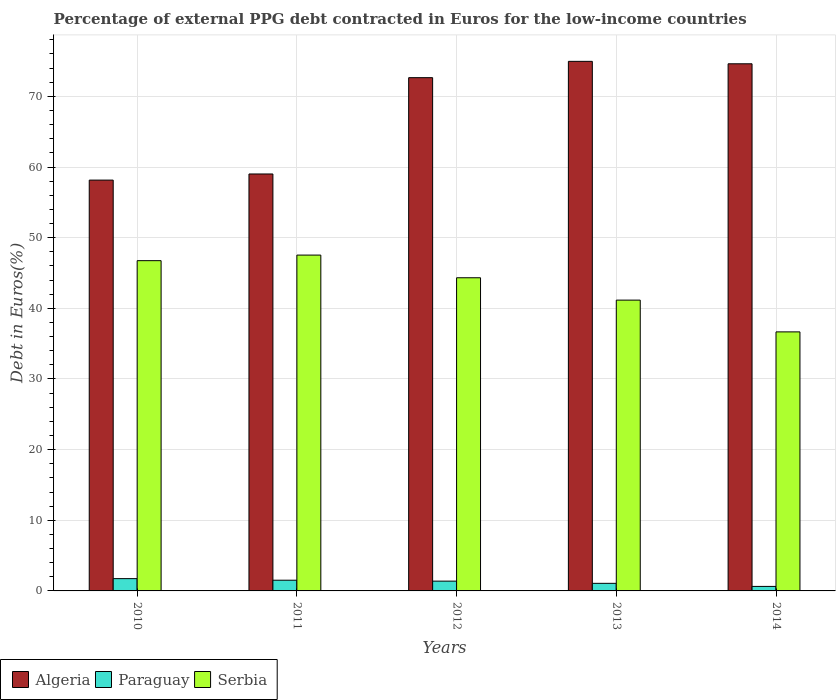Are the number of bars per tick equal to the number of legend labels?
Your response must be concise. Yes. Are the number of bars on each tick of the X-axis equal?
Offer a very short reply. Yes. How many bars are there on the 3rd tick from the left?
Offer a terse response. 3. What is the label of the 1st group of bars from the left?
Ensure brevity in your answer.  2010. What is the percentage of external PPG debt contracted in Euros in Serbia in 2013?
Keep it short and to the point. 41.16. Across all years, what is the maximum percentage of external PPG debt contracted in Euros in Paraguay?
Your answer should be compact. 1.74. Across all years, what is the minimum percentage of external PPG debt contracted in Euros in Algeria?
Keep it short and to the point. 58.15. In which year was the percentage of external PPG debt contracted in Euros in Serbia maximum?
Ensure brevity in your answer.  2011. What is the total percentage of external PPG debt contracted in Euros in Paraguay in the graph?
Your answer should be very brief. 6.35. What is the difference between the percentage of external PPG debt contracted in Euros in Algeria in 2010 and that in 2011?
Your response must be concise. -0.87. What is the difference between the percentage of external PPG debt contracted in Euros in Paraguay in 2010 and the percentage of external PPG debt contracted in Euros in Algeria in 2012?
Make the answer very short. -70.91. What is the average percentage of external PPG debt contracted in Euros in Algeria per year?
Your response must be concise. 67.87. In the year 2013, what is the difference between the percentage of external PPG debt contracted in Euros in Paraguay and percentage of external PPG debt contracted in Euros in Serbia?
Keep it short and to the point. -40.09. What is the ratio of the percentage of external PPG debt contracted in Euros in Algeria in 2012 to that in 2013?
Offer a terse response. 0.97. What is the difference between the highest and the second highest percentage of external PPG debt contracted in Euros in Paraguay?
Offer a terse response. 0.22. What is the difference between the highest and the lowest percentage of external PPG debt contracted in Euros in Paraguay?
Give a very brief answer. 1.1. What does the 2nd bar from the left in 2012 represents?
Offer a very short reply. Paraguay. What does the 3rd bar from the right in 2012 represents?
Ensure brevity in your answer.  Algeria. How many bars are there?
Provide a succinct answer. 15. Are all the bars in the graph horizontal?
Give a very brief answer. No. How many years are there in the graph?
Keep it short and to the point. 5. What is the difference between two consecutive major ticks on the Y-axis?
Make the answer very short. 10. How many legend labels are there?
Your response must be concise. 3. How are the legend labels stacked?
Provide a succinct answer. Horizontal. What is the title of the graph?
Provide a short and direct response. Percentage of external PPG debt contracted in Euros for the low-income countries. Does "Spain" appear as one of the legend labels in the graph?
Make the answer very short. No. What is the label or title of the X-axis?
Your response must be concise. Years. What is the label or title of the Y-axis?
Offer a very short reply. Debt in Euros(%). What is the Debt in Euros(%) in Algeria in 2010?
Your response must be concise. 58.15. What is the Debt in Euros(%) of Paraguay in 2010?
Provide a succinct answer. 1.74. What is the Debt in Euros(%) in Serbia in 2010?
Offer a terse response. 46.74. What is the Debt in Euros(%) in Algeria in 2011?
Make the answer very short. 59.01. What is the Debt in Euros(%) of Paraguay in 2011?
Your response must be concise. 1.52. What is the Debt in Euros(%) in Serbia in 2011?
Your response must be concise. 47.53. What is the Debt in Euros(%) in Algeria in 2012?
Make the answer very short. 72.64. What is the Debt in Euros(%) of Paraguay in 2012?
Your response must be concise. 1.39. What is the Debt in Euros(%) in Serbia in 2012?
Provide a short and direct response. 44.32. What is the Debt in Euros(%) in Algeria in 2013?
Provide a short and direct response. 74.95. What is the Debt in Euros(%) in Paraguay in 2013?
Offer a very short reply. 1.07. What is the Debt in Euros(%) of Serbia in 2013?
Provide a short and direct response. 41.16. What is the Debt in Euros(%) in Algeria in 2014?
Offer a terse response. 74.61. What is the Debt in Euros(%) in Paraguay in 2014?
Offer a terse response. 0.64. What is the Debt in Euros(%) of Serbia in 2014?
Offer a terse response. 36.66. Across all years, what is the maximum Debt in Euros(%) in Algeria?
Your answer should be compact. 74.95. Across all years, what is the maximum Debt in Euros(%) in Paraguay?
Provide a succinct answer. 1.74. Across all years, what is the maximum Debt in Euros(%) of Serbia?
Your response must be concise. 47.53. Across all years, what is the minimum Debt in Euros(%) of Algeria?
Offer a terse response. 58.15. Across all years, what is the minimum Debt in Euros(%) of Paraguay?
Your answer should be very brief. 0.64. Across all years, what is the minimum Debt in Euros(%) of Serbia?
Offer a terse response. 36.66. What is the total Debt in Euros(%) in Algeria in the graph?
Your answer should be compact. 339.37. What is the total Debt in Euros(%) of Paraguay in the graph?
Ensure brevity in your answer.  6.35. What is the total Debt in Euros(%) in Serbia in the graph?
Provide a short and direct response. 216.42. What is the difference between the Debt in Euros(%) in Algeria in 2010 and that in 2011?
Your answer should be compact. -0.87. What is the difference between the Debt in Euros(%) in Paraguay in 2010 and that in 2011?
Keep it short and to the point. 0.22. What is the difference between the Debt in Euros(%) in Serbia in 2010 and that in 2011?
Make the answer very short. -0.79. What is the difference between the Debt in Euros(%) in Algeria in 2010 and that in 2012?
Provide a short and direct response. -14.5. What is the difference between the Debt in Euros(%) of Paraguay in 2010 and that in 2012?
Offer a very short reply. 0.35. What is the difference between the Debt in Euros(%) in Serbia in 2010 and that in 2012?
Ensure brevity in your answer.  2.42. What is the difference between the Debt in Euros(%) in Algeria in 2010 and that in 2013?
Your response must be concise. -16.81. What is the difference between the Debt in Euros(%) in Paraguay in 2010 and that in 2013?
Give a very brief answer. 0.66. What is the difference between the Debt in Euros(%) of Serbia in 2010 and that in 2013?
Provide a succinct answer. 5.58. What is the difference between the Debt in Euros(%) in Algeria in 2010 and that in 2014?
Provide a short and direct response. -16.46. What is the difference between the Debt in Euros(%) in Paraguay in 2010 and that in 2014?
Your answer should be compact. 1.1. What is the difference between the Debt in Euros(%) of Serbia in 2010 and that in 2014?
Keep it short and to the point. 10.08. What is the difference between the Debt in Euros(%) in Algeria in 2011 and that in 2012?
Your answer should be compact. -13.63. What is the difference between the Debt in Euros(%) of Paraguay in 2011 and that in 2012?
Make the answer very short. 0.13. What is the difference between the Debt in Euros(%) of Serbia in 2011 and that in 2012?
Ensure brevity in your answer.  3.21. What is the difference between the Debt in Euros(%) in Algeria in 2011 and that in 2013?
Your response must be concise. -15.94. What is the difference between the Debt in Euros(%) of Paraguay in 2011 and that in 2013?
Offer a very short reply. 0.44. What is the difference between the Debt in Euros(%) of Serbia in 2011 and that in 2013?
Your response must be concise. 6.37. What is the difference between the Debt in Euros(%) in Algeria in 2011 and that in 2014?
Your response must be concise. -15.6. What is the difference between the Debt in Euros(%) of Paraguay in 2011 and that in 2014?
Your answer should be compact. 0.88. What is the difference between the Debt in Euros(%) in Serbia in 2011 and that in 2014?
Ensure brevity in your answer.  10.87. What is the difference between the Debt in Euros(%) of Algeria in 2012 and that in 2013?
Keep it short and to the point. -2.31. What is the difference between the Debt in Euros(%) of Paraguay in 2012 and that in 2013?
Your answer should be compact. 0.31. What is the difference between the Debt in Euros(%) in Serbia in 2012 and that in 2013?
Provide a succinct answer. 3.16. What is the difference between the Debt in Euros(%) in Algeria in 2012 and that in 2014?
Give a very brief answer. -1.96. What is the difference between the Debt in Euros(%) of Paraguay in 2012 and that in 2014?
Your answer should be very brief. 0.75. What is the difference between the Debt in Euros(%) in Serbia in 2012 and that in 2014?
Provide a short and direct response. 7.66. What is the difference between the Debt in Euros(%) in Algeria in 2013 and that in 2014?
Offer a terse response. 0.34. What is the difference between the Debt in Euros(%) in Paraguay in 2013 and that in 2014?
Offer a terse response. 0.44. What is the difference between the Debt in Euros(%) of Serbia in 2013 and that in 2014?
Give a very brief answer. 4.5. What is the difference between the Debt in Euros(%) in Algeria in 2010 and the Debt in Euros(%) in Paraguay in 2011?
Your answer should be very brief. 56.63. What is the difference between the Debt in Euros(%) in Algeria in 2010 and the Debt in Euros(%) in Serbia in 2011?
Keep it short and to the point. 10.61. What is the difference between the Debt in Euros(%) in Paraguay in 2010 and the Debt in Euros(%) in Serbia in 2011?
Provide a succinct answer. -45.79. What is the difference between the Debt in Euros(%) of Algeria in 2010 and the Debt in Euros(%) of Paraguay in 2012?
Ensure brevity in your answer.  56.76. What is the difference between the Debt in Euros(%) of Algeria in 2010 and the Debt in Euros(%) of Serbia in 2012?
Provide a short and direct response. 13.82. What is the difference between the Debt in Euros(%) in Paraguay in 2010 and the Debt in Euros(%) in Serbia in 2012?
Offer a terse response. -42.58. What is the difference between the Debt in Euros(%) in Algeria in 2010 and the Debt in Euros(%) in Paraguay in 2013?
Offer a terse response. 57.07. What is the difference between the Debt in Euros(%) in Algeria in 2010 and the Debt in Euros(%) in Serbia in 2013?
Provide a short and direct response. 16.99. What is the difference between the Debt in Euros(%) in Paraguay in 2010 and the Debt in Euros(%) in Serbia in 2013?
Make the answer very short. -39.42. What is the difference between the Debt in Euros(%) in Algeria in 2010 and the Debt in Euros(%) in Paraguay in 2014?
Your response must be concise. 57.51. What is the difference between the Debt in Euros(%) of Algeria in 2010 and the Debt in Euros(%) of Serbia in 2014?
Keep it short and to the point. 21.48. What is the difference between the Debt in Euros(%) of Paraguay in 2010 and the Debt in Euros(%) of Serbia in 2014?
Ensure brevity in your answer.  -34.92. What is the difference between the Debt in Euros(%) in Algeria in 2011 and the Debt in Euros(%) in Paraguay in 2012?
Offer a very short reply. 57.63. What is the difference between the Debt in Euros(%) in Algeria in 2011 and the Debt in Euros(%) in Serbia in 2012?
Your answer should be very brief. 14.69. What is the difference between the Debt in Euros(%) of Paraguay in 2011 and the Debt in Euros(%) of Serbia in 2012?
Make the answer very short. -42.81. What is the difference between the Debt in Euros(%) of Algeria in 2011 and the Debt in Euros(%) of Paraguay in 2013?
Ensure brevity in your answer.  57.94. What is the difference between the Debt in Euros(%) in Algeria in 2011 and the Debt in Euros(%) in Serbia in 2013?
Make the answer very short. 17.85. What is the difference between the Debt in Euros(%) in Paraguay in 2011 and the Debt in Euros(%) in Serbia in 2013?
Your answer should be compact. -39.64. What is the difference between the Debt in Euros(%) of Algeria in 2011 and the Debt in Euros(%) of Paraguay in 2014?
Give a very brief answer. 58.38. What is the difference between the Debt in Euros(%) of Algeria in 2011 and the Debt in Euros(%) of Serbia in 2014?
Ensure brevity in your answer.  22.35. What is the difference between the Debt in Euros(%) of Paraguay in 2011 and the Debt in Euros(%) of Serbia in 2014?
Provide a succinct answer. -35.15. What is the difference between the Debt in Euros(%) of Algeria in 2012 and the Debt in Euros(%) of Paraguay in 2013?
Give a very brief answer. 71.57. What is the difference between the Debt in Euros(%) of Algeria in 2012 and the Debt in Euros(%) of Serbia in 2013?
Give a very brief answer. 31.49. What is the difference between the Debt in Euros(%) of Paraguay in 2012 and the Debt in Euros(%) of Serbia in 2013?
Offer a very short reply. -39.77. What is the difference between the Debt in Euros(%) in Algeria in 2012 and the Debt in Euros(%) in Paraguay in 2014?
Offer a very short reply. 72.01. What is the difference between the Debt in Euros(%) in Algeria in 2012 and the Debt in Euros(%) in Serbia in 2014?
Offer a terse response. 35.98. What is the difference between the Debt in Euros(%) of Paraguay in 2012 and the Debt in Euros(%) of Serbia in 2014?
Your answer should be compact. -35.28. What is the difference between the Debt in Euros(%) in Algeria in 2013 and the Debt in Euros(%) in Paraguay in 2014?
Give a very brief answer. 74.32. What is the difference between the Debt in Euros(%) of Algeria in 2013 and the Debt in Euros(%) of Serbia in 2014?
Your answer should be very brief. 38.29. What is the difference between the Debt in Euros(%) in Paraguay in 2013 and the Debt in Euros(%) in Serbia in 2014?
Provide a short and direct response. -35.59. What is the average Debt in Euros(%) of Algeria per year?
Your answer should be very brief. 67.87. What is the average Debt in Euros(%) in Paraguay per year?
Your response must be concise. 1.27. What is the average Debt in Euros(%) in Serbia per year?
Offer a very short reply. 43.28. In the year 2010, what is the difference between the Debt in Euros(%) of Algeria and Debt in Euros(%) of Paraguay?
Give a very brief answer. 56.41. In the year 2010, what is the difference between the Debt in Euros(%) in Algeria and Debt in Euros(%) in Serbia?
Provide a succinct answer. 11.4. In the year 2010, what is the difference between the Debt in Euros(%) of Paraguay and Debt in Euros(%) of Serbia?
Your response must be concise. -45. In the year 2011, what is the difference between the Debt in Euros(%) in Algeria and Debt in Euros(%) in Paraguay?
Provide a short and direct response. 57.5. In the year 2011, what is the difference between the Debt in Euros(%) in Algeria and Debt in Euros(%) in Serbia?
Offer a terse response. 11.48. In the year 2011, what is the difference between the Debt in Euros(%) in Paraguay and Debt in Euros(%) in Serbia?
Make the answer very short. -46.02. In the year 2012, what is the difference between the Debt in Euros(%) in Algeria and Debt in Euros(%) in Paraguay?
Your response must be concise. 71.26. In the year 2012, what is the difference between the Debt in Euros(%) of Algeria and Debt in Euros(%) of Serbia?
Keep it short and to the point. 28.32. In the year 2012, what is the difference between the Debt in Euros(%) in Paraguay and Debt in Euros(%) in Serbia?
Your answer should be compact. -42.94. In the year 2013, what is the difference between the Debt in Euros(%) of Algeria and Debt in Euros(%) of Paraguay?
Provide a short and direct response. 73.88. In the year 2013, what is the difference between the Debt in Euros(%) of Algeria and Debt in Euros(%) of Serbia?
Offer a very short reply. 33.79. In the year 2013, what is the difference between the Debt in Euros(%) of Paraguay and Debt in Euros(%) of Serbia?
Provide a succinct answer. -40.09. In the year 2014, what is the difference between the Debt in Euros(%) in Algeria and Debt in Euros(%) in Paraguay?
Give a very brief answer. 73.97. In the year 2014, what is the difference between the Debt in Euros(%) in Algeria and Debt in Euros(%) in Serbia?
Make the answer very short. 37.95. In the year 2014, what is the difference between the Debt in Euros(%) in Paraguay and Debt in Euros(%) in Serbia?
Make the answer very short. -36.03. What is the ratio of the Debt in Euros(%) of Paraguay in 2010 to that in 2011?
Offer a very short reply. 1.15. What is the ratio of the Debt in Euros(%) in Serbia in 2010 to that in 2011?
Keep it short and to the point. 0.98. What is the ratio of the Debt in Euros(%) of Algeria in 2010 to that in 2012?
Your response must be concise. 0.8. What is the ratio of the Debt in Euros(%) of Paraguay in 2010 to that in 2012?
Offer a terse response. 1.25. What is the ratio of the Debt in Euros(%) in Serbia in 2010 to that in 2012?
Your response must be concise. 1.05. What is the ratio of the Debt in Euros(%) in Algeria in 2010 to that in 2013?
Provide a short and direct response. 0.78. What is the ratio of the Debt in Euros(%) of Paraguay in 2010 to that in 2013?
Your answer should be very brief. 1.62. What is the ratio of the Debt in Euros(%) in Serbia in 2010 to that in 2013?
Your response must be concise. 1.14. What is the ratio of the Debt in Euros(%) in Algeria in 2010 to that in 2014?
Your answer should be compact. 0.78. What is the ratio of the Debt in Euros(%) of Paraguay in 2010 to that in 2014?
Your answer should be compact. 2.73. What is the ratio of the Debt in Euros(%) in Serbia in 2010 to that in 2014?
Your response must be concise. 1.27. What is the ratio of the Debt in Euros(%) of Algeria in 2011 to that in 2012?
Offer a terse response. 0.81. What is the ratio of the Debt in Euros(%) in Paraguay in 2011 to that in 2012?
Make the answer very short. 1.09. What is the ratio of the Debt in Euros(%) in Serbia in 2011 to that in 2012?
Offer a terse response. 1.07. What is the ratio of the Debt in Euros(%) of Algeria in 2011 to that in 2013?
Your answer should be compact. 0.79. What is the ratio of the Debt in Euros(%) of Paraguay in 2011 to that in 2013?
Your answer should be very brief. 1.41. What is the ratio of the Debt in Euros(%) of Serbia in 2011 to that in 2013?
Ensure brevity in your answer.  1.15. What is the ratio of the Debt in Euros(%) in Algeria in 2011 to that in 2014?
Your answer should be compact. 0.79. What is the ratio of the Debt in Euros(%) in Paraguay in 2011 to that in 2014?
Provide a short and direct response. 2.38. What is the ratio of the Debt in Euros(%) in Serbia in 2011 to that in 2014?
Give a very brief answer. 1.3. What is the ratio of the Debt in Euros(%) in Algeria in 2012 to that in 2013?
Ensure brevity in your answer.  0.97. What is the ratio of the Debt in Euros(%) in Paraguay in 2012 to that in 2013?
Keep it short and to the point. 1.29. What is the ratio of the Debt in Euros(%) of Serbia in 2012 to that in 2013?
Your response must be concise. 1.08. What is the ratio of the Debt in Euros(%) in Algeria in 2012 to that in 2014?
Your response must be concise. 0.97. What is the ratio of the Debt in Euros(%) in Paraguay in 2012 to that in 2014?
Your answer should be very brief. 2.17. What is the ratio of the Debt in Euros(%) in Serbia in 2012 to that in 2014?
Your response must be concise. 1.21. What is the ratio of the Debt in Euros(%) of Algeria in 2013 to that in 2014?
Your answer should be compact. 1. What is the ratio of the Debt in Euros(%) in Paraguay in 2013 to that in 2014?
Provide a succinct answer. 1.69. What is the ratio of the Debt in Euros(%) in Serbia in 2013 to that in 2014?
Ensure brevity in your answer.  1.12. What is the difference between the highest and the second highest Debt in Euros(%) of Algeria?
Ensure brevity in your answer.  0.34. What is the difference between the highest and the second highest Debt in Euros(%) of Paraguay?
Keep it short and to the point. 0.22. What is the difference between the highest and the second highest Debt in Euros(%) of Serbia?
Offer a terse response. 0.79. What is the difference between the highest and the lowest Debt in Euros(%) in Algeria?
Your answer should be very brief. 16.81. What is the difference between the highest and the lowest Debt in Euros(%) of Paraguay?
Offer a terse response. 1.1. What is the difference between the highest and the lowest Debt in Euros(%) of Serbia?
Make the answer very short. 10.87. 